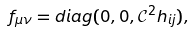<formula> <loc_0><loc_0><loc_500><loc_500>f _ { \mu \nu } = d i a g ( 0 , 0 , \mathcal { C } ^ { 2 } h _ { i j } ) ,</formula> 